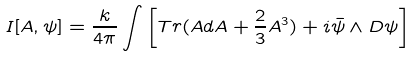<formula> <loc_0><loc_0><loc_500><loc_500>I [ A , \psi ] = \frac { k } { 4 \pi } \int \left [ T r ( A d A + \frac { 2 } { 3 } A ^ { 3 } ) + i \bar { \psi } \wedge D \psi \right ]</formula> 